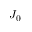<formula> <loc_0><loc_0><loc_500><loc_500>J _ { 0 }</formula> 